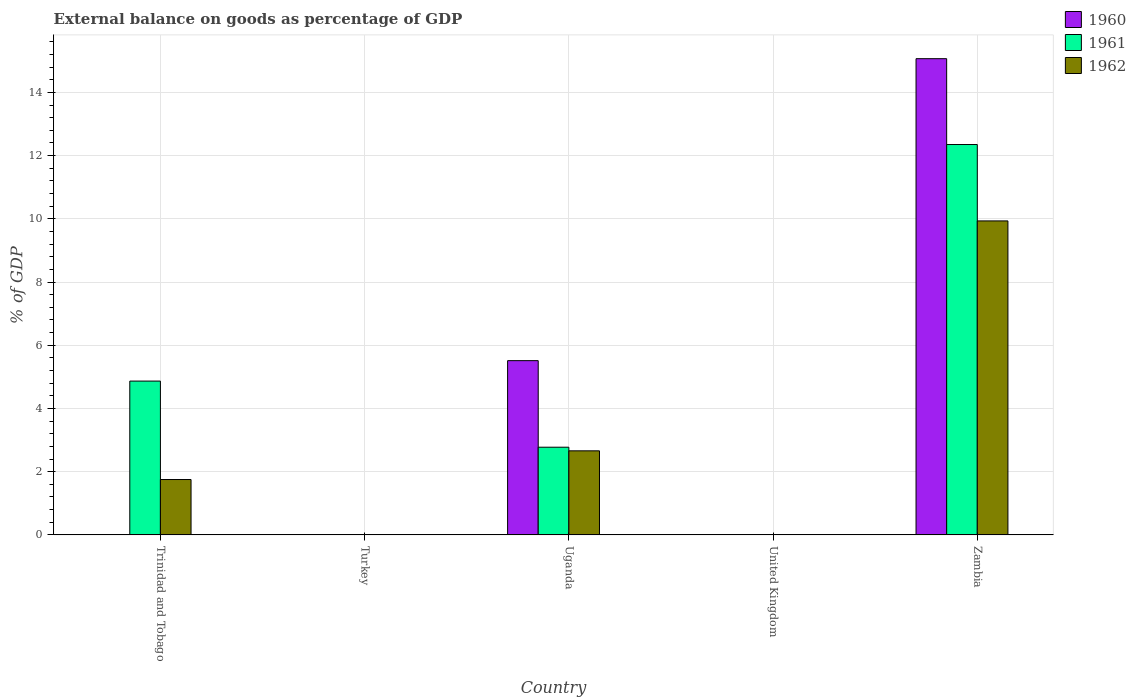How many bars are there on the 3rd tick from the right?
Give a very brief answer. 3. What is the label of the 5th group of bars from the left?
Give a very brief answer. Zambia. Across all countries, what is the maximum external balance on goods as percentage of GDP in 1960?
Provide a succinct answer. 15.07. In which country was the external balance on goods as percentage of GDP in 1960 maximum?
Offer a very short reply. Zambia. What is the total external balance on goods as percentage of GDP in 1961 in the graph?
Offer a very short reply. 19.99. What is the difference between the external balance on goods as percentage of GDP in 1961 in Trinidad and Tobago and that in Zambia?
Provide a short and direct response. -7.48. What is the difference between the external balance on goods as percentage of GDP in 1960 in Uganda and the external balance on goods as percentage of GDP in 1961 in Turkey?
Your answer should be very brief. 5.51. What is the average external balance on goods as percentage of GDP in 1960 per country?
Your answer should be very brief. 4.12. What is the difference between the external balance on goods as percentage of GDP of/in 1962 and external balance on goods as percentage of GDP of/in 1961 in Trinidad and Tobago?
Offer a very short reply. -3.11. In how many countries, is the external balance on goods as percentage of GDP in 1961 greater than 2 %?
Offer a terse response. 3. What is the ratio of the external balance on goods as percentage of GDP in 1961 in Trinidad and Tobago to that in Uganda?
Provide a short and direct response. 1.75. Is the external balance on goods as percentage of GDP in 1961 in Uganda less than that in Zambia?
Your response must be concise. Yes. Is the difference between the external balance on goods as percentage of GDP in 1962 in Trinidad and Tobago and Uganda greater than the difference between the external balance on goods as percentage of GDP in 1961 in Trinidad and Tobago and Uganda?
Provide a succinct answer. No. What is the difference between the highest and the second highest external balance on goods as percentage of GDP in 1961?
Offer a terse response. -9.58. What is the difference between the highest and the lowest external balance on goods as percentage of GDP in 1961?
Your answer should be very brief. 12.35. Is the sum of the external balance on goods as percentage of GDP in 1961 in Trinidad and Tobago and Zambia greater than the maximum external balance on goods as percentage of GDP in 1962 across all countries?
Ensure brevity in your answer.  Yes. What is the difference between two consecutive major ticks on the Y-axis?
Provide a short and direct response. 2. Are the values on the major ticks of Y-axis written in scientific E-notation?
Provide a succinct answer. No. Does the graph contain grids?
Keep it short and to the point. Yes. How many legend labels are there?
Your answer should be compact. 3. What is the title of the graph?
Give a very brief answer. External balance on goods as percentage of GDP. What is the label or title of the X-axis?
Your answer should be very brief. Country. What is the label or title of the Y-axis?
Ensure brevity in your answer.  % of GDP. What is the % of GDP in 1960 in Trinidad and Tobago?
Your answer should be very brief. 0. What is the % of GDP of 1961 in Trinidad and Tobago?
Offer a terse response. 4.87. What is the % of GDP of 1962 in Trinidad and Tobago?
Your answer should be very brief. 1.75. What is the % of GDP in 1961 in Turkey?
Make the answer very short. 0. What is the % of GDP of 1962 in Turkey?
Provide a short and direct response. 0. What is the % of GDP of 1960 in Uganda?
Your answer should be very brief. 5.51. What is the % of GDP of 1961 in Uganda?
Your answer should be compact. 2.77. What is the % of GDP of 1962 in Uganda?
Your response must be concise. 2.66. What is the % of GDP in 1961 in United Kingdom?
Provide a succinct answer. 0. What is the % of GDP in 1962 in United Kingdom?
Provide a succinct answer. 0. What is the % of GDP of 1960 in Zambia?
Provide a short and direct response. 15.07. What is the % of GDP in 1961 in Zambia?
Ensure brevity in your answer.  12.35. What is the % of GDP in 1962 in Zambia?
Your answer should be compact. 9.93. Across all countries, what is the maximum % of GDP in 1960?
Offer a terse response. 15.07. Across all countries, what is the maximum % of GDP of 1961?
Keep it short and to the point. 12.35. Across all countries, what is the maximum % of GDP in 1962?
Ensure brevity in your answer.  9.93. Across all countries, what is the minimum % of GDP of 1960?
Ensure brevity in your answer.  0. Across all countries, what is the minimum % of GDP of 1961?
Make the answer very short. 0. Across all countries, what is the minimum % of GDP of 1962?
Offer a very short reply. 0. What is the total % of GDP in 1960 in the graph?
Offer a very short reply. 20.58. What is the total % of GDP of 1961 in the graph?
Offer a terse response. 19.99. What is the total % of GDP of 1962 in the graph?
Provide a succinct answer. 14.35. What is the difference between the % of GDP of 1961 in Trinidad and Tobago and that in Uganda?
Offer a very short reply. 2.09. What is the difference between the % of GDP of 1962 in Trinidad and Tobago and that in Uganda?
Offer a terse response. -0.91. What is the difference between the % of GDP of 1961 in Trinidad and Tobago and that in Zambia?
Your answer should be very brief. -7.49. What is the difference between the % of GDP of 1962 in Trinidad and Tobago and that in Zambia?
Your answer should be compact. -8.18. What is the difference between the % of GDP in 1960 in Uganda and that in Zambia?
Give a very brief answer. -9.55. What is the difference between the % of GDP of 1961 in Uganda and that in Zambia?
Provide a succinct answer. -9.58. What is the difference between the % of GDP of 1962 in Uganda and that in Zambia?
Your response must be concise. -7.27. What is the difference between the % of GDP in 1961 in Trinidad and Tobago and the % of GDP in 1962 in Uganda?
Provide a succinct answer. 2.21. What is the difference between the % of GDP in 1961 in Trinidad and Tobago and the % of GDP in 1962 in Zambia?
Provide a succinct answer. -5.07. What is the difference between the % of GDP of 1960 in Uganda and the % of GDP of 1961 in Zambia?
Your answer should be very brief. -6.84. What is the difference between the % of GDP of 1960 in Uganda and the % of GDP of 1962 in Zambia?
Offer a terse response. -4.42. What is the difference between the % of GDP of 1961 in Uganda and the % of GDP of 1962 in Zambia?
Ensure brevity in your answer.  -7.16. What is the average % of GDP of 1960 per country?
Provide a succinct answer. 4.12. What is the average % of GDP of 1961 per country?
Provide a succinct answer. 4. What is the average % of GDP of 1962 per country?
Offer a terse response. 2.87. What is the difference between the % of GDP in 1961 and % of GDP in 1962 in Trinidad and Tobago?
Offer a terse response. 3.11. What is the difference between the % of GDP in 1960 and % of GDP in 1961 in Uganda?
Offer a terse response. 2.74. What is the difference between the % of GDP of 1960 and % of GDP of 1962 in Uganda?
Your answer should be very brief. 2.85. What is the difference between the % of GDP in 1961 and % of GDP in 1962 in Uganda?
Your answer should be very brief. 0.11. What is the difference between the % of GDP in 1960 and % of GDP in 1961 in Zambia?
Provide a short and direct response. 2.72. What is the difference between the % of GDP in 1960 and % of GDP in 1962 in Zambia?
Give a very brief answer. 5.13. What is the difference between the % of GDP in 1961 and % of GDP in 1962 in Zambia?
Offer a very short reply. 2.42. What is the ratio of the % of GDP in 1961 in Trinidad and Tobago to that in Uganda?
Ensure brevity in your answer.  1.75. What is the ratio of the % of GDP in 1962 in Trinidad and Tobago to that in Uganda?
Your answer should be compact. 0.66. What is the ratio of the % of GDP of 1961 in Trinidad and Tobago to that in Zambia?
Make the answer very short. 0.39. What is the ratio of the % of GDP in 1962 in Trinidad and Tobago to that in Zambia?
Provide a succinct answer. 0.18. What is the ratio of the % of GDP in 1960 in Uganda to that in Zambia?
Your answer should be very brief. 0.37. What is the ratio of the % of GDP of 1961 in Uganda to that in Zambia?
Your response must be concise. 0.22. What is the ratio of the % of GDP of 1962 in Uganda to that in Zambia?
Your answer should be compact. 0.27. What is the difference between the highest and the second highest % of GDP of 1961?
Ensure brevity in your answer.  7.49. What is the difference between the highest and the second highest % of GDP in 1962?
Make the answer very short. 7.27. What is the difference between the highest and the lowest % of GDP in 1960?
Keep it short and to the point. 15.07. What is the difference between the highest and the lowest % of GDP in 1961?
Provide a short and direct response. 12.35. What is the difference between the highest and the lowest % of GDP in 1962?
Give a very brief answer. 9.93. 